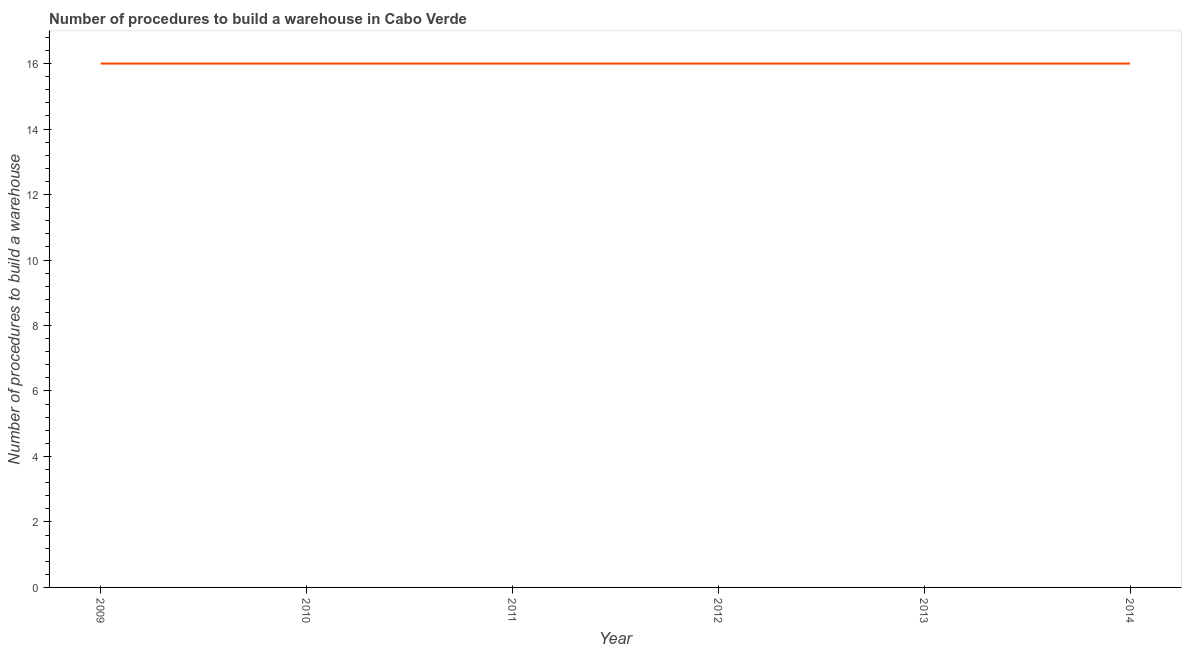What is the number of procedures to build a warehouse in 2012?
Give a very brief answer. 16. Across all years, what is the maximum number of procedures to build a warehouse?
Your response must be concise. 16. Across all years, what is the minimum number of procedures to build a warehouse?
Make the answer very short. 16. In which year was the number of procedures to build a warehouse maximum?
Ensure brevity in your answer.  2009. In which year was the number of procedures to build a warehouse minimum?
Offer a very short reply. 2009. What is the sum of the number of procedures to build a warehouse?
Provide a short and direct response. 96. What is the average number of procedures to build a warehouse per year?
Offer a very short reply. 16. What is the median number of procedures to build a warehouse?
Offer a terse response. 16. Do a majority of the years between 2013 and 2014 (inclusive) have number of procedures to build a warehouse greater than 12 ?
Keep it short and to the point. Yes. Is the number of procedures to build a warehouse in 2013 less than that in 2014?
Your answer should be very brief. No. Is the difference between the number of procedures to build a warehouse in 2012 and 2014 greater than the difference between any two years?
Keep it short and to the point. Yes. What is the difference between the highest and the second highest number of procedures to build a warehouse?
Make the answer very short. 0. In how many years, is the number of procedures to build a warehouse greater than the average number of procedures to build a warehouse taken over all years?
Your response must be concise. 0. How many lines are there?
Provide a short and direct response. 1. Are the values on the major ticks of Y-axis written in scientific E-notation?
Your response must be concise. No. Does the graph contain any zero values?
Offer a terse response. No. Does the graph contain grids?
Your answer should be very brief. No. What is the title of the graph?
Offer a very short reply. Number of procedures to build a warehouse in Cabo Verde. What is the label or title of the X-axis?
Provide a short and direct response. Year. What is the label or title of the Y-axis?
Your answer should be compact. Number of procedures to build a warehouse. What is the Number of procedures to build a warehouse of 2013?
Provide a short and direct response. 16. What is the difference between the Number of procedures to build a warehouse in 2009 and 2010?
Your answer should be very brief. 0. What is the difference between the Number of procedures to build a warehouse in 2009 and 2011?
Provide a succinct answer. 0. What is the difference between the Number of procedures to build a warehouse in 2009 and 2012?
Your answer should be compact. 0. What is the difference between the Number of procedures to build a warehouse in 2009 and 2013?
Keep it short and to the point. 0. What is the difference between the Number of procedures to build a warehouse in 2009 and 2014?
Provide a short and direct response. 0. What is the difference between the Number of procedures to build a warehouse in 2010 and 2011?
Make the answer very short. 0. What is the difference between the Number of procedures to build a warehouse in 2010 and 2012?
Offer a terse response. 0. What is the difference between the Number of procedures to build a warehouse in 2010 and 2013?
Keep it short and to the point. 0. What is the difference between the Number of procedures to build a warehouse in 2010 and 2014?
Offer a terse response. 0. What is the difference between the Number of procedures to build a warehouse in 2012 and 2013?
Keep it short and to the point. 0. What is the ratio of the Number of procedures to build a warehouse in 2009 to that in 2014?
Your answer should be compact. 1. What is the ratio of the Number of procedures to build a warehouse in 2010 to that in 2011?
Your answer should be compact. 1. What is the ratio of the Number of procedures to build a warehouse in 2010 to that in 2013?
Offer a terse response. 1. What is the ratio of the Number of procedures to build a warehouse in 2010 to that in 2014?
Ensure brevity in your answer.  1. What is the ratio of the Number of procedures to build a warehouse in 2011 to that in 2012?
Give a very brief answer. 1. What is the ratio of the Number of procedures to build a warehouse in 2011 to that in 2013?
Ensure brevity in your answer.  1. What is the ratio of the Number of procedures to build a warehouse in 2011 to that in 2014?
Give a very brief answer. 1. What is the ratio of the Number of procedures to build a warehouse in 2013 to that in 2014?
Your response must be concise. 1. 